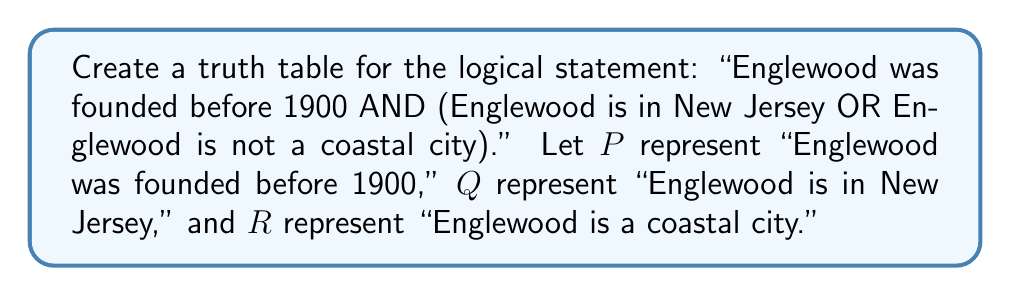Provide a solution to this math problem. Let's approach this step-by-step:

1) First, we need to translate the statement into Boolean algebra:
   $P \land (Q \lor \lnot R)$

2) We have three variables (P, Q, R), so our truth table will have $2^3 = 8$ rows.

3) Let's set up the truth table with columns for P, Q, R, and the final result:

   | P | Q | R | $P \land (Q \lor \lnot R)$ |
   |---|---|---|---------------------------|
   | 0 | 0 | 0 |                           |
   | 0 | 0 | 1 |                           |
   | 0 | 1 | 0 |                           |
   | 0 | 1 | 1 |                           |
   | 1 | 0 | 0 |                           |
   | 1 | 0 | 1 |                           |
   | 1 | 1 | 0 |                           |
   | 1 | 1 | 1 |                           |

4) Now, let's evaluate $(Q \lor \lnot R)$ first:

   | P | Q | R | $\lnot R$ | $Q \lor \lnot R$ |
   |---|---|---|----------|------------------|
   | 0 | 0 | 0 |    1     |        1         |
   | 0 | 0 | 1 |    0     |        0         |
   | 0 | 1 | 0 |    1     |        1         |
   | 0 | 1 | 1 |    0     |        1         |
   | 1 | 0 | 0 |    1     |        1         |
   | 1 | 0 | 1 |    0     |        0         |
   | 1 | 1 | 0 |    1     |        1         |
   | 1 | 1 | 1 |    0     |        1         |

5) Finally, we can evaluate $P \land (Q \lor \lnot R)$:

   | P | Q | R | $Q \lor \lnot R$ | $P \land (Q \lor \lnot R)$ |
   |---|---|---|------------------|---------------------------|
   | 0 | 0 | 0 |        1         |             0             |
   | 0 | 0 | 1 |        0         |             0             |
   | 0 | 1 | 0 |        1         |             0             |
   | 0 | 1 | 1 |        1         |             0             |
   | 1 | 0 | 0 |        1         |             1             |
   | 1 | 0 | 1 |        0         |             0             |
   | 1 | 1 | 0 |        1         |             1             |
   | 1 | 1 | 1 |        1         |             1             |

This completes our truth table for the given logical statement about Englewood's founding.
Answer: | P | Q | R | $P \land (Q \lor \lnot R)$ |
|---|---|---|---------------------------|
| 0 | 0 | 0 |             0             |
| 0 | 0 | 1 |             0             |
| 0 | 1 | 0 |             0             |
| 0 | 1 | 1 |             0             |
| 1 | 0 | 0 |             1             |
| 1 | 0 | 1 |             0             |
| 1 | 1 | 0 |             1             |
| 1 | 1 | 1 |             1             | 